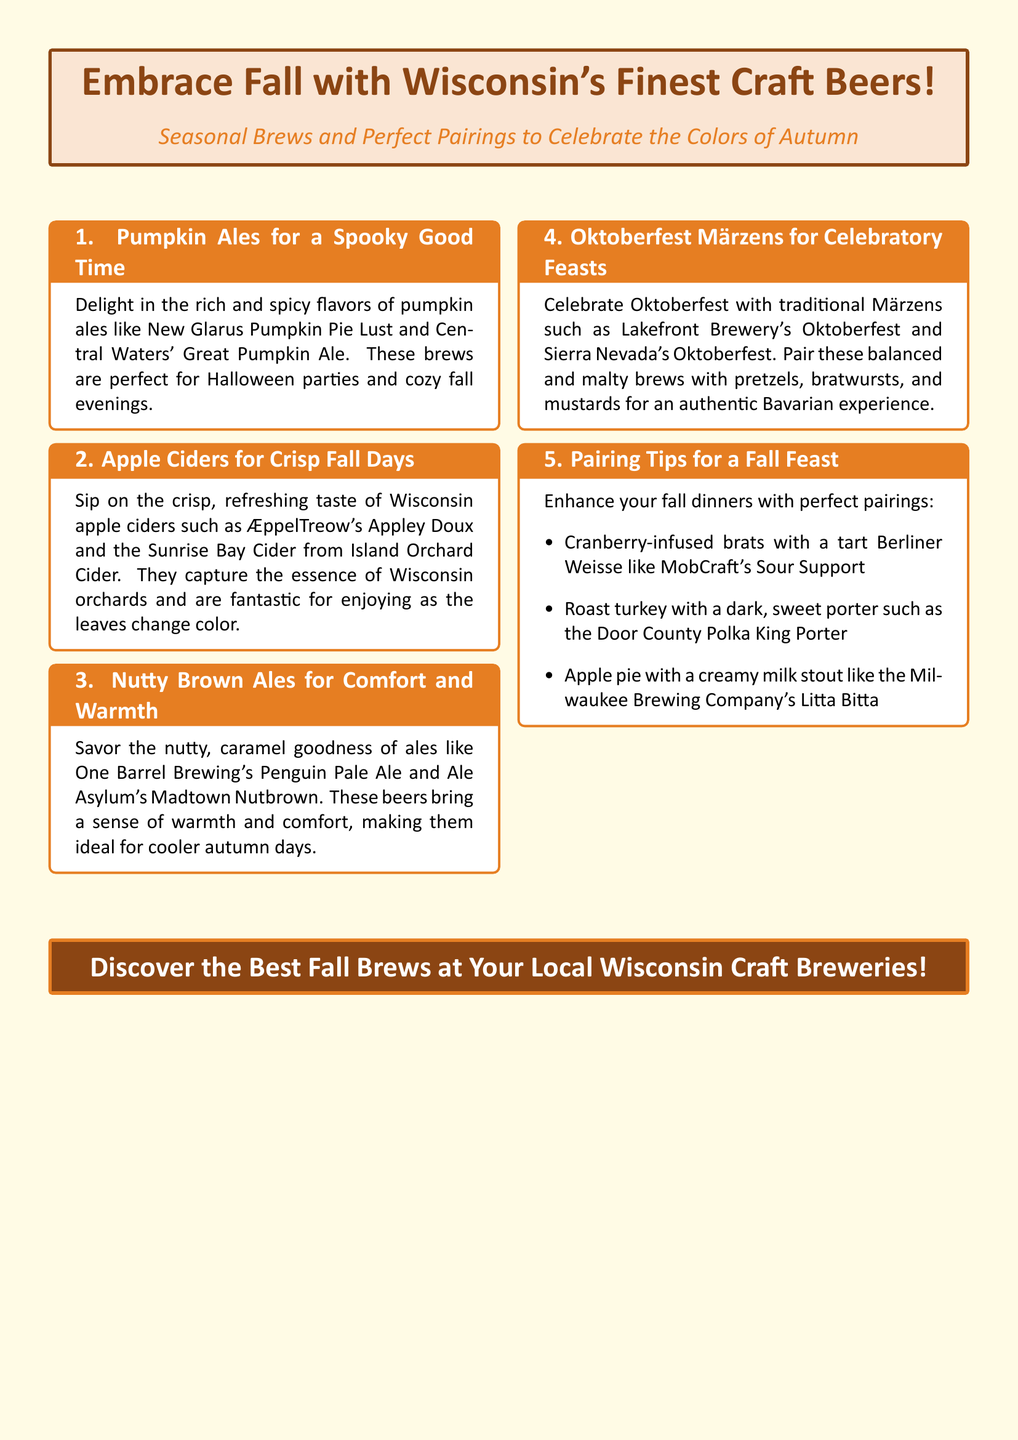What is the title of the advertisement? The title is presented prominently within the document, asserting the main theme of the advertisement.
Answer: Embrace Fall with Wisconsin's Finest Craft Beers! Which seasonal brew is highlighted for Halloween? The document specifically mentions a type of beer perfect for Halloween celebrations.
Answer: Pumpkin Ales What type of cider is recommended for fall days? The advertisement lists a specific type of beverage ideal for enjoying during the autumn season.
Answer: Apple Ciders How many pairing tips are provided for a fall feast? The document enumerates a specific number of tips for pairing beverages and food in the autumn season.
Answer: Three Which Märzen is recommended for Oktoberfest? The advertisement suggests a specific Märzen beer that aligns with September celebrations.
Answer: Lakefront Brewery's Oktoberfest What is the suggested pairing for roast turkey? Among the pairing tips, the document outlines a specific drink to enjoy with turkey dishes.
Answer: Dark, sweet porter What is the base color theme of the document? The advertisement employs a specific color as the backdrop to enhance its autumn theme.
Answer: Autumn yellow 